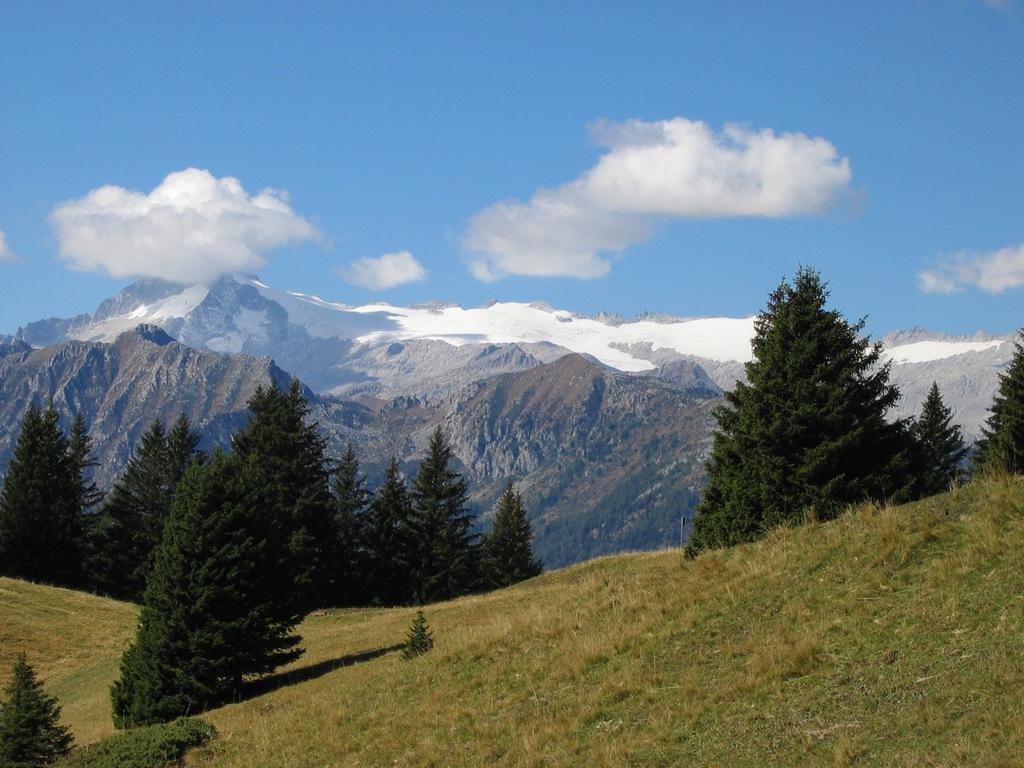How would you summarize this image in a sentence or two? In this picture I can see trees, hills, I can see snow on the hills and grass on the ground. I can see a blue cloudy sky. 